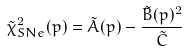<formula> <loc_0><loc_0><loc_500><loc_500>\tilde { \chi } ^ { 2 } _ { S N e } ( p ) = \tilde { A } ( p ) - \frac { \tilde { B } ( p ) ^ { 2 } } { \tilde { C } }</formula> 